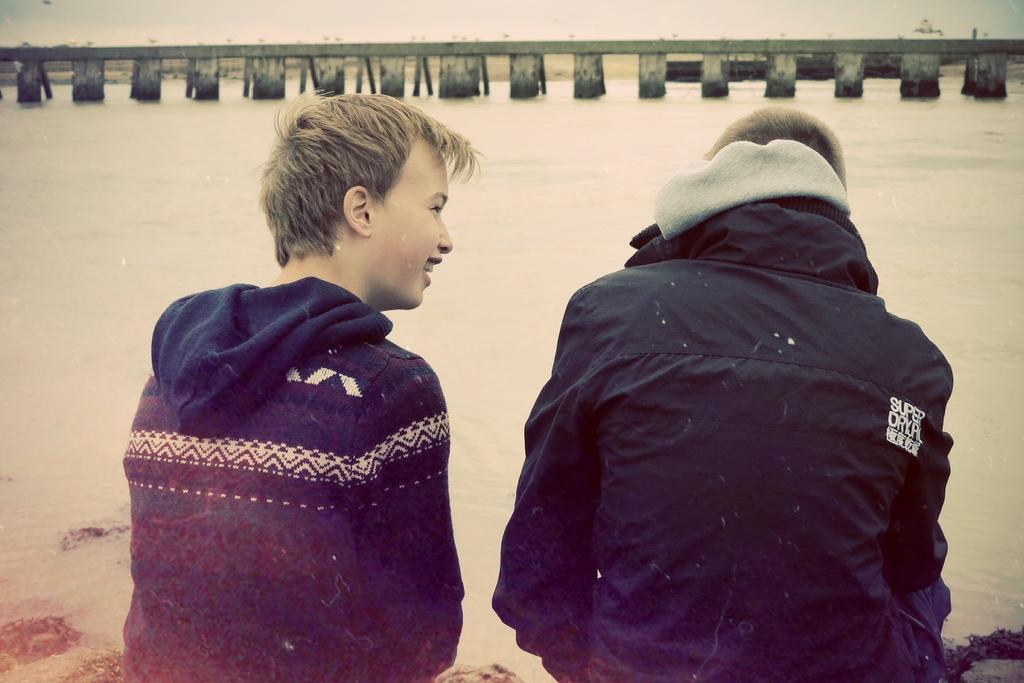How many people are in the image? There are two persons in the image. What is in front of the persons? There is water in front of the persons. What can be seen in the background of the image? There is a bridge with pillars in the background of the image. What type of cherries are being picked by the kittens in the image? There are no cherries or kittens present in the image. 